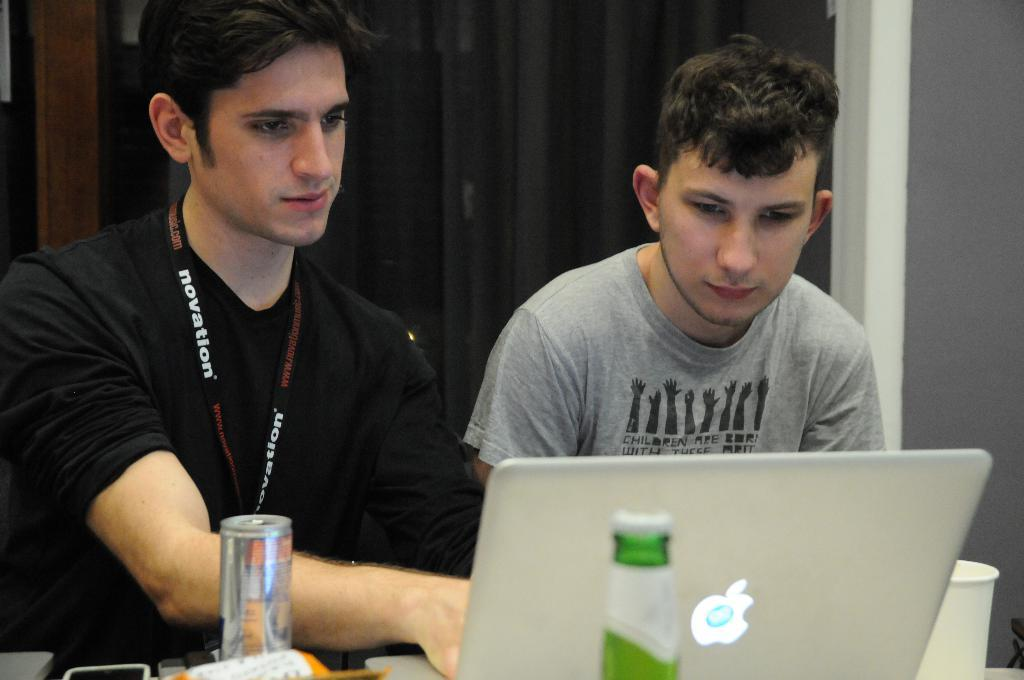How many people are sitting in the image in the image? There are two persons sitting in the image. What objects can be seen in the image besides the people? There is a bottle, a glass, a tin, and a laptop in the image. What might the people be using to drink in the image? They might be using the glass or the bottle to drink. What is the laptop being used for in the image? The laptop's purpose cannot be determined from the image alone. What is on the object that the other items are placed on? There are other items on an object in the image, but their nature cannot be determined from the facts provided. What is visible in the background of the image? There is a wall in the background of the image. What is the value of the government in the image? There is no reference to a government or any values in the image, so it's not possible to determine the value of the government. 